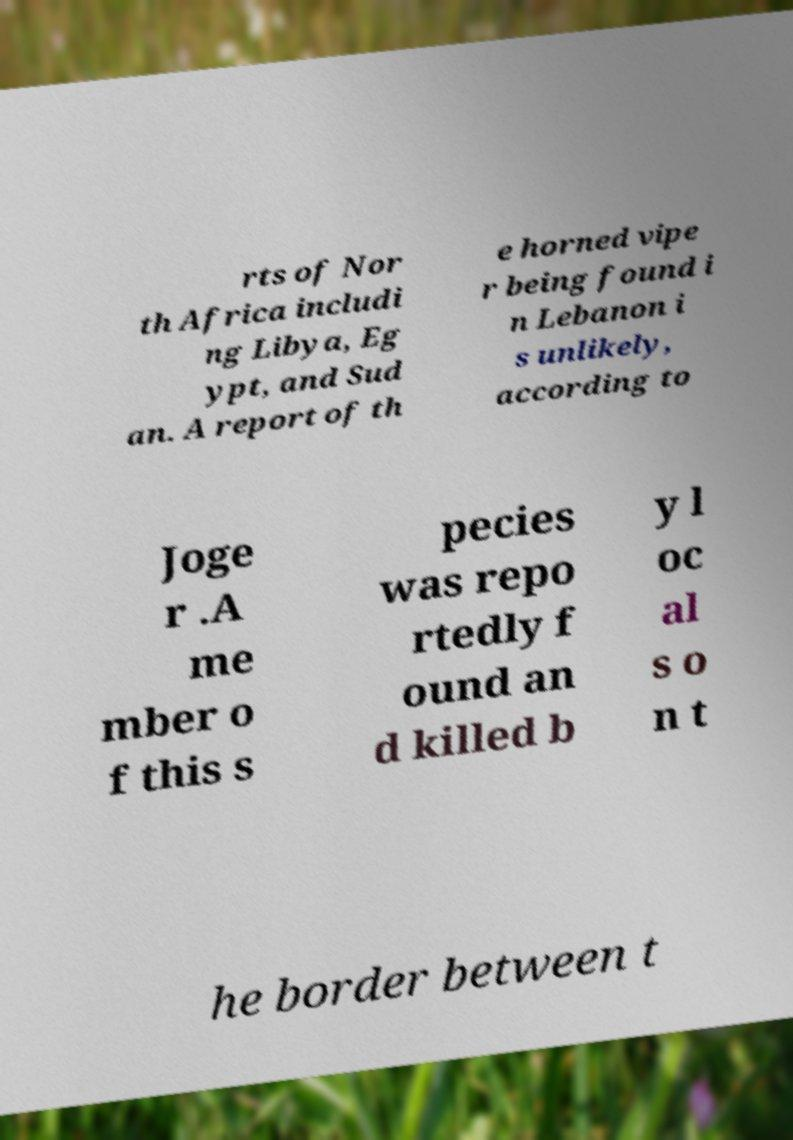Please read and relay the text visible in this image. What does it say? rts of Nor th Africa includi ng Libya, Eg ypt, and Sud an. A report of th e horned vipe r being found i n Lebanon i s unlikely, according to Joge r .A me mber o f this s pecies was repo rtedly f ound an d killed b y l oc al s o n t he border between t 